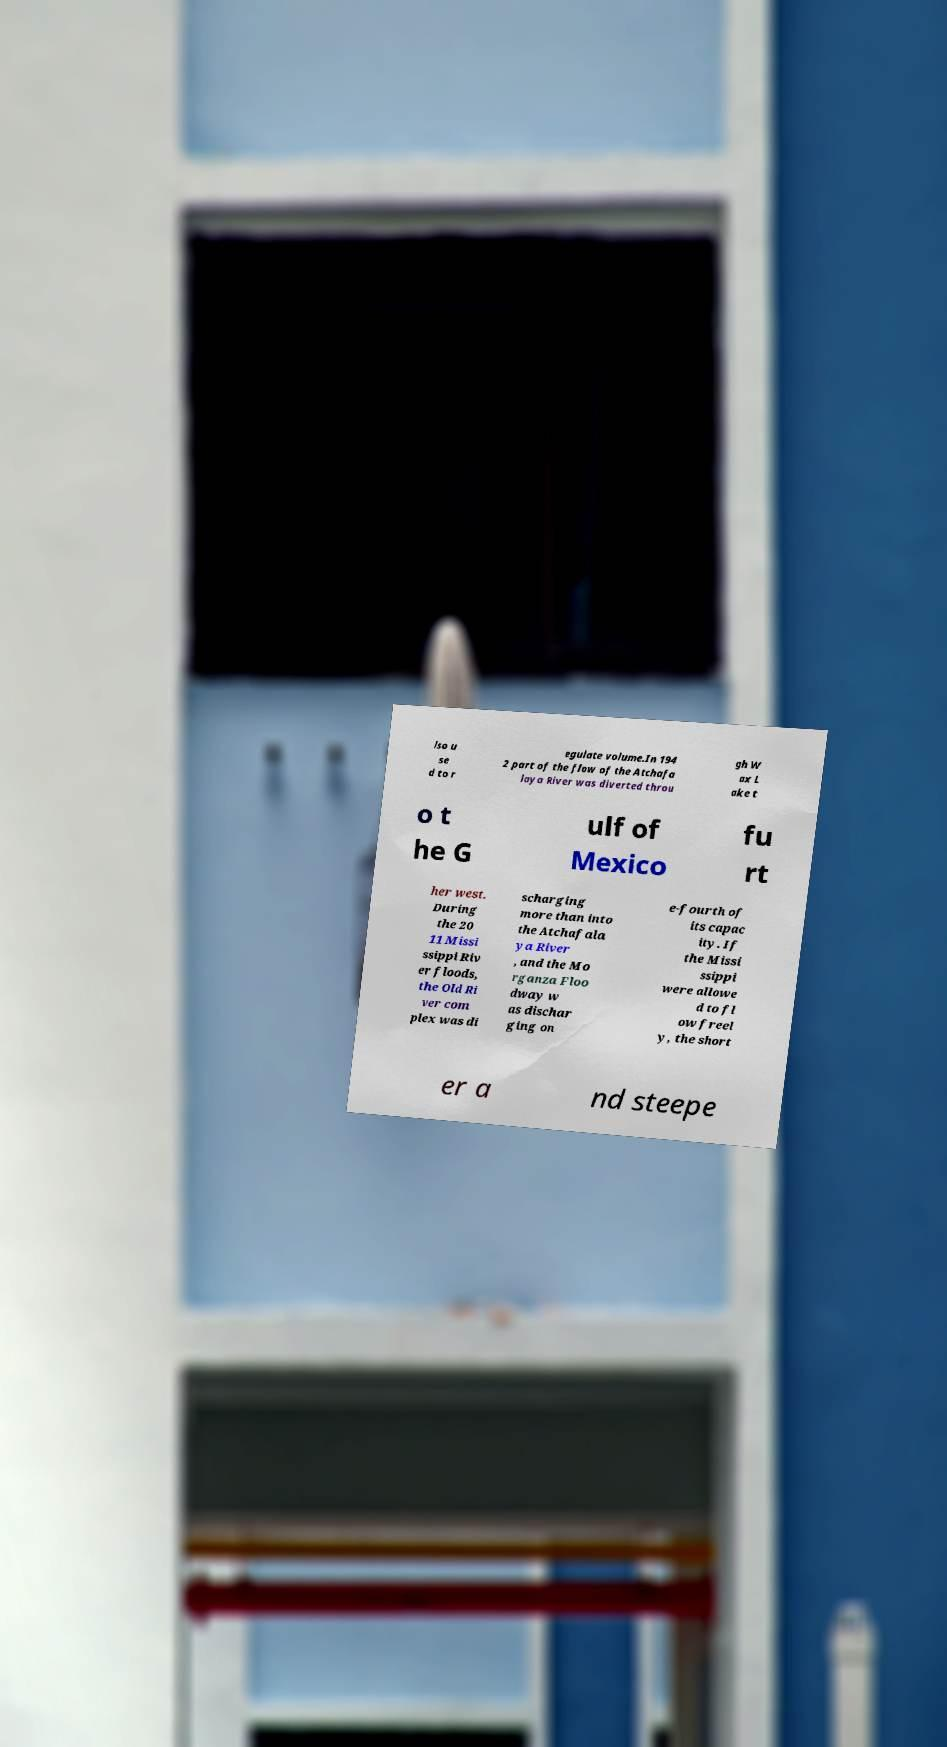For documentation purposes, I need the text within this image transcribed. Could you provide that? lso u se d to r egulate volume.In 194 2 part of the flow of the Atchafa laya River was diverted throu gh W ax L ake t o t he G ulf of Mexico fu rt her west. During the 20 11 Missi ssippi Riv er floods, the Old Ri ver com plex was di scharging more than into the Atchafala ya River , and the Mo rganza Floo dway w as dischar ging on e-fourth of its capac ity. If the Missi ssippi were allowe d to fl ow freel y, the short er a nd steepe 